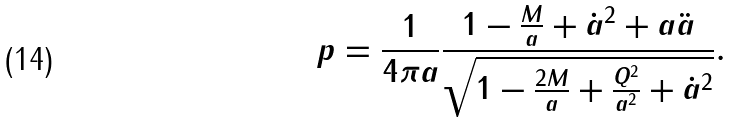<formula> <loc_0><loc_0><loc_500><loc_500>p = \frac { 1 } { 4 \pi a } \frac { 1 - \frac { M } { a } + \dot { a } ^ { 2 } + a \ddot { a } } { \sqrt { 1 - \frac { 2 M } { a } + \frac { Q ^ { 2 } } { a ^ { 2 } } + \dot { a } ^ { 2 } } } .</formula> 